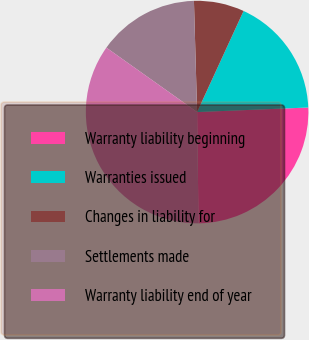Convert chart to OTSL. <chart><loc_0><loc_0><loc_500><loc_500><pie_chart><fcel>Warranty liability beginning<fcel>Warranties issued<fcel>Changes in liability for<fcel>Settlements made<fcel>Warranty liability end of year<nl><fcel>25.45%<fcel>17.49%<fcel>7.31%<fcel>14.72%<fcel>35.03%<nl></chart> 